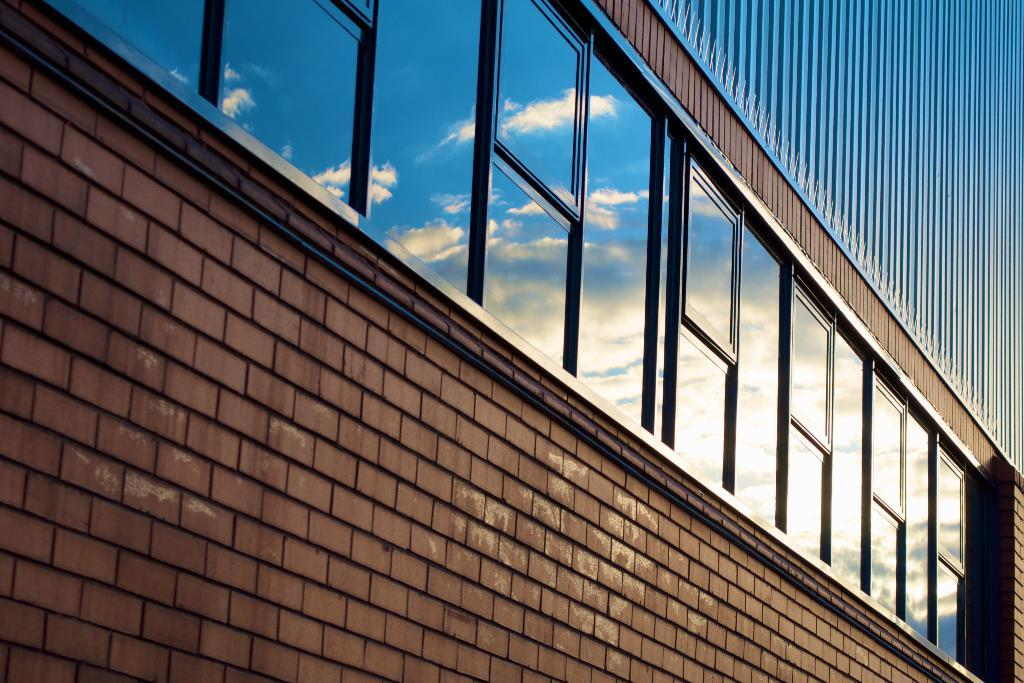What structure is present in the image? There is a building in the image. What objects are visible in the image? There are glasses in the image. What do the glasses reflect? The glasses reflect the sky. What can be seen in the sky's reflection on the glasses? Clouds are visible in the sky's reflection on the glasses. What type of plant is growing on the glasses in the image? There is no plant growing on the glasses in the image. How does the acoustics of the building affect the sound in the image? The provided facts do not mention anything about the acoustics of the building or the sound in the image. Can you describe the knot tied on the glasses in the image? There is no knot tied on the glasses in the image. 